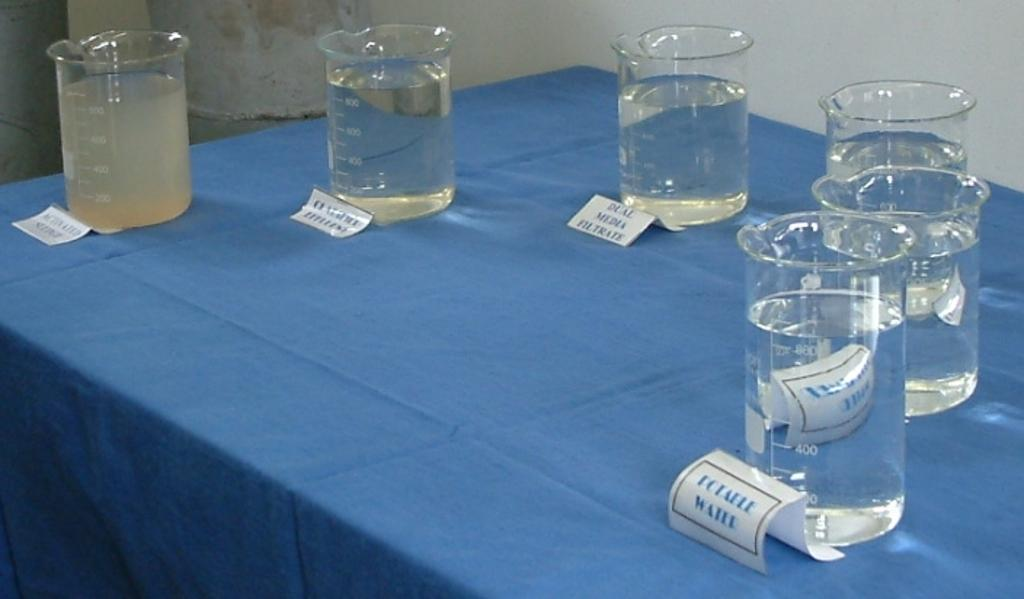<image>
Give a short and clear explanation of the subsequent image. Six glass containers of water are on the table and the one closest indicates it is potable water. 